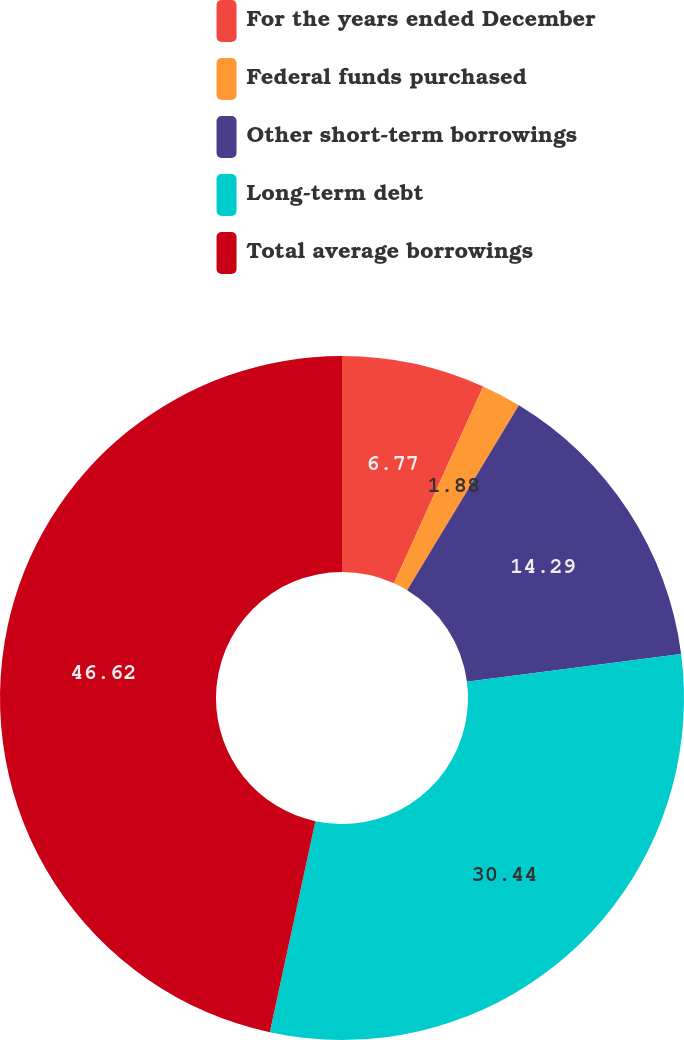<chart> <loc_0><loc_0><loc_500><loc_500><pie_chart><fcel>For the years ended December<fcel>Federal funds purchased<fcel>Other short-term borrowings<fcel>Long-term debt<fcel>Total average borrowings<nl><fcel>6.77%<fcel>1.88%<fcel>14.29%<fcel>30.44%<fcel>46.61%<nl></chart> 